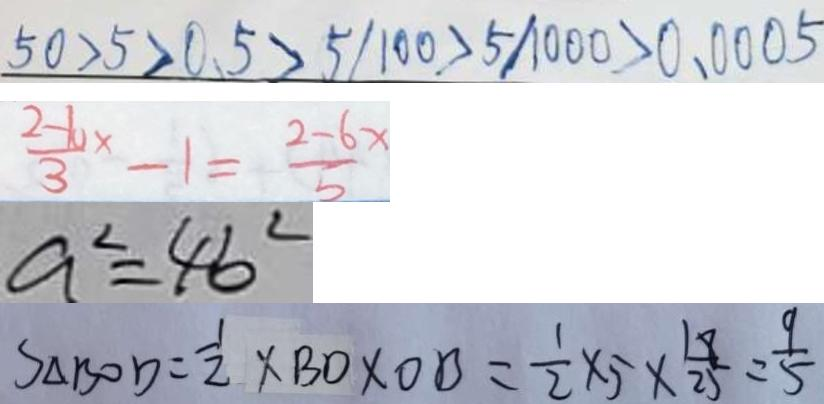Convert formula to latex. <formula><loc_0><loc_0><loc_500><loc_500>5 0 > 5 > 0 . 5 > 5 / 1 0 0 > 5 / 1 0 0 0 > 0 . 0 0 0 5 
 \frac { 2 - 1 0 x } { 3 } - 1 = \frac { 2 - 6 x } { 5 } 
 a ^ { 2 } = 4 b ^ { 2 } 
 S _ { \Delta B O D } = \frac { 1 } { 2 } \times B D \times O B = \frac { 1 } { 2 } \times 5 \times \frac { 1 8 } { 2 5 } = \frac { 9 } { 5 }</formula> 